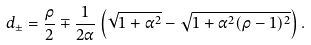<formula> <loc_0><loc_0><loc_500><loc_500>d _ { \pm } = \frac { \rho } { 2 } \mp \frac { 1 } { 2 \alpha } \left ( \sqrt { 1 + \alpha ^ { 2 } } - \sqrt { 1 + \alpha ^ { 2 } ( \rho - 1 ) ^ { 2 } } \right ) .</formula> 